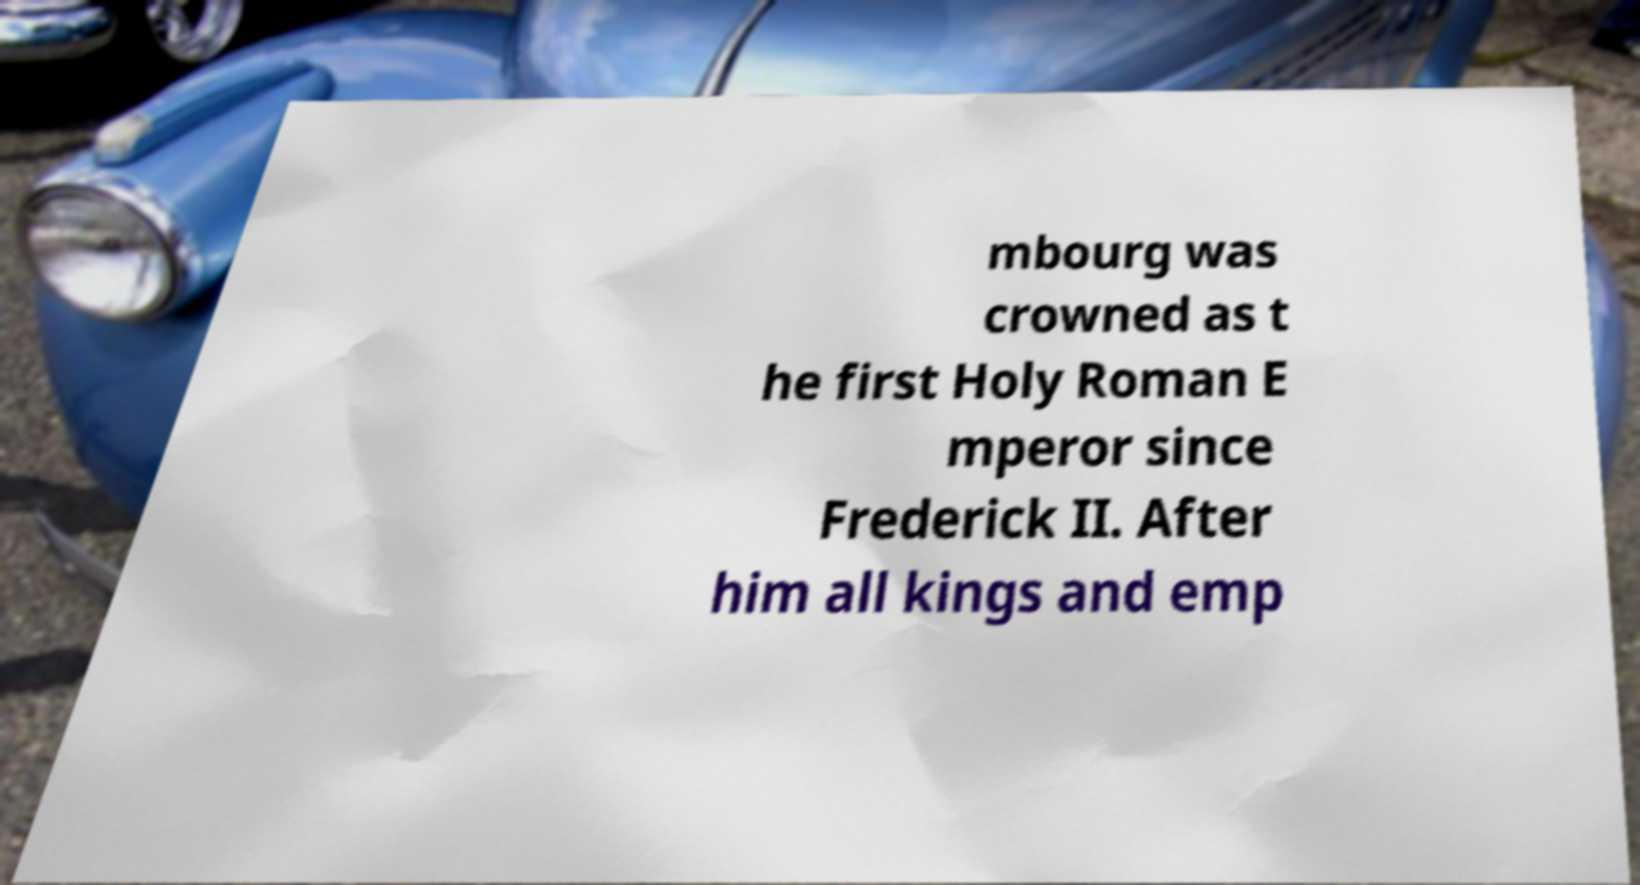Can you accurately transcribe the text from the provided image for me? mbourg was crowned as t he first Holy Roman E mperor since Frederick II. After him all kings and emp 